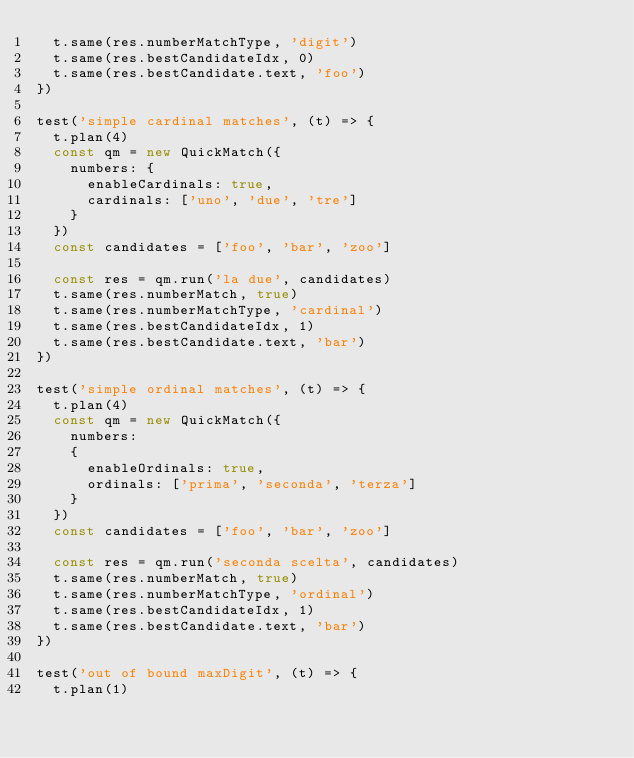<code> <loc_0><loc_0><loc_500><loc_500><_JavaScript_>  t.same(res.numberMatchType, 'digit')
  t.same(res.bestCandidateIdx, 0)
  t.same(res.bestCandidate.text, 'foo')
})

test('simple cardinal matches', (t) => {
  t.plan(4)
  const qm = new QuickMatch({
    numbers: {
      enableCardinals: true,
      cardinals: ['uno', 'due', 'tre']
    }
  })
  const candidates = ['foo', 'bar', 'zoo']

  const res = qm.run('la due', candidates)
  t.same(res.numberMatch, true)
  t.same(res.numberMatchType, 'cardinal')
  t.same(res.bestCandidateIdx, 1)
  t.same(res.bestCandidate.text, 'bar')
})

test('simple ordinal matches', (t) => {
  t.plan(4)
  const qm = new QuickMatch({
    numbers:
    {
      enableOrdinals: true,
      ordinals: ['prima', 'seconda', 'terza']
    }
  })
  const candidates = ['foo', 'bar', 'zoo']

  const res = qm.run('seconda scelta', candidates)
  t.same(res.numberMatch, true)
  t.same(res.numberMatchType, 'ordinal')
  t.same(res.bestCandidateIdx, 1)
  t.same(res.bestCandidate.text, 'bar')
})

test('out of bound maxDigit', (t) => {
  t.plan(1)</code> 